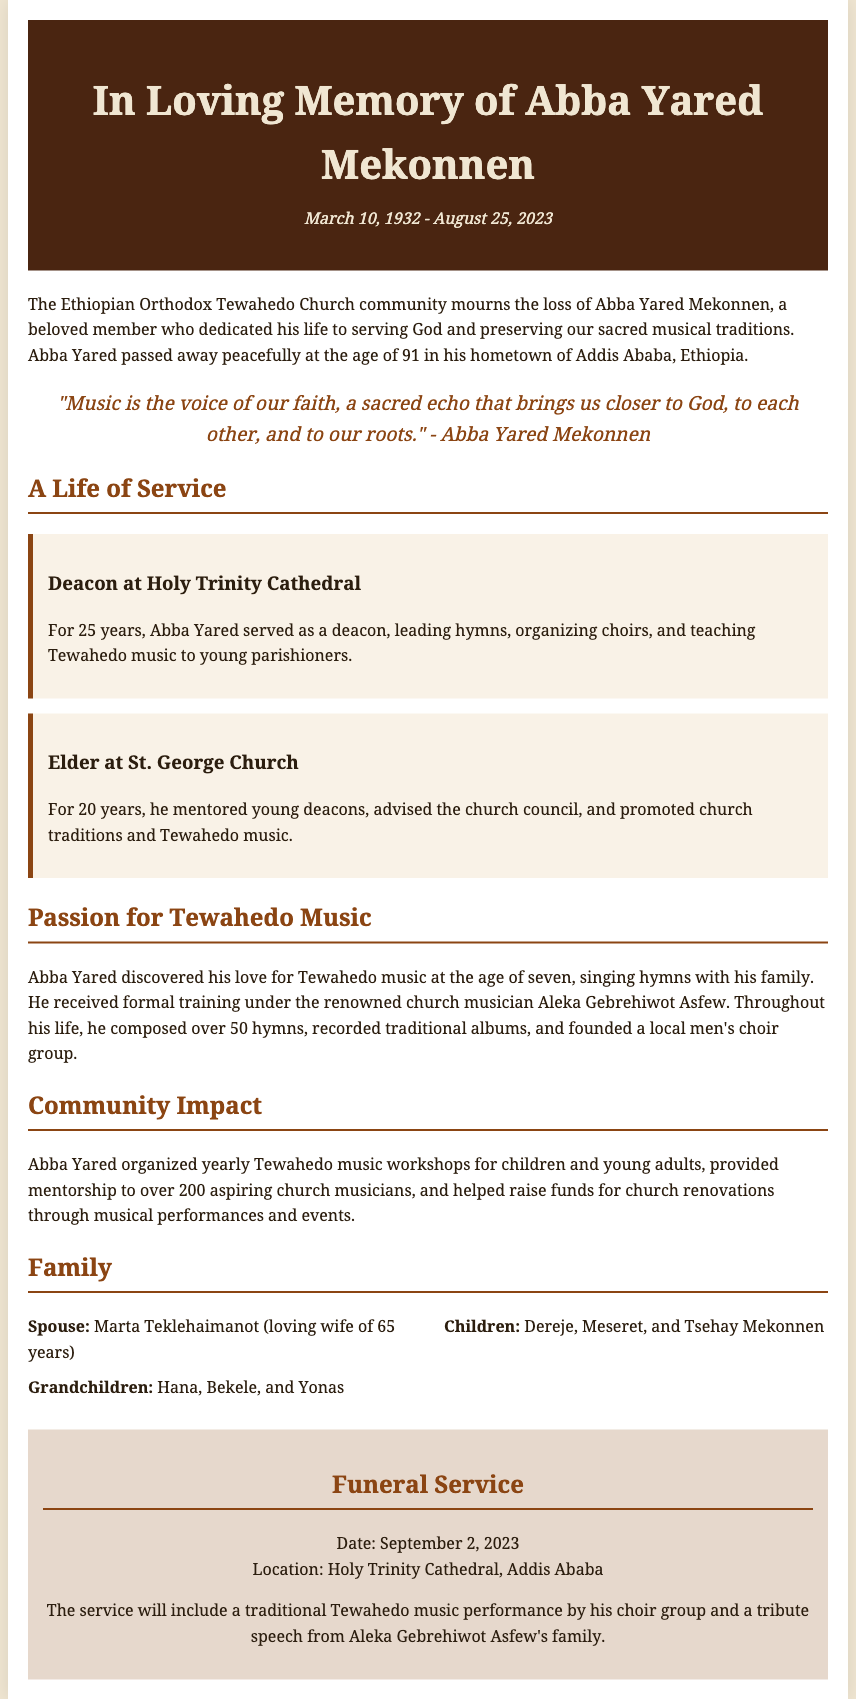What was Abba Yared Mekonnen's age at death? The document states Abba Yared passed away at the age of 91.
Answer: 91 In which city did Abba Yared Mekonnen pass away? The obituary mentions that he passed away in Addis Ababa, Ethiopia.
Answer: Addis Ababa How many years did Abba Yared serve as a deacon at Holy Trinity Cathedral? The document indicates he served for 25 years.
Answer: 25 years What was the name of Abba Yared Mekonnen's wife? The obituary specifies his wife's name as Marta Teklehaimanot.
Answer: Marta Teklehaimanot Which renowned church musician provided training to Abba Yared? The document mentions he was trained by Aleka Gebrehiwot Asfew.
Answer: Aleka Gebrehiwot Asfew What was the date of Abba Yared Mekonnen's funeral service? The document states the funeral service was held on September 2, 2023.
Answer: September 2, 2023 How many hymns did Abba Yared compose in his lifetime? The obituary notes that he composed over 50 hymns.
Answer: Over 50 hymns What role did Abba Yared have at St. George Church? The document describes him as an elder at St. George Church.
Answer: Elder What special performance was included in the funeral service? The obituary mentions a traditional Tewahedo music performance by his choir group.
Answer: Traditional Tewahedo music performance 